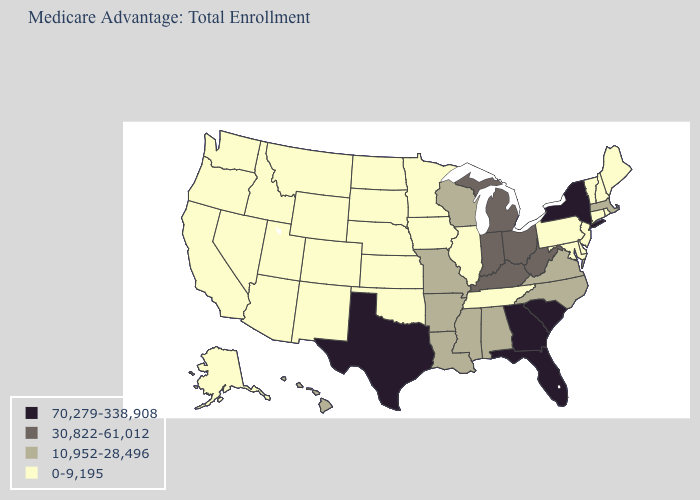What is the highest value in states that border Kentucky?
Write a very short answer. 30,822-61,012. Does the map have missing data?
Be succinct. No. Among the states that border Rhode Island , does Massachusetts have the highest value?
Write a very short answer. Yes. Does the map have missing data?
Quick response, please. No. Name the states that have a value in the range 10,952-28,496?
Be succinct. Alabama, Arkansas, Hawaii, Louisiana, Massachusetts, Missouri, Mississippi, North Carolina, Virginia, Wisconsin. Does Indiana have the lowest value in the USA?
Answer briefly. No. Among the states that border Indiana , which have the highest value?
Give a very brief answer. Kentucky, Michigan, Ohio. Does the first symbol in the legend represent the smallest category?
Short answer required. No. Does the first symbol in the legend represent the smallest category?
Give a very brief answer. No. What is the highest value in the USA?
Keep it brief. 70,279-338,908. Among the states that border Rhode Island , does Connecticut have the lowest value?
Be succinct. Yes. What is the lowest value in the USA?
Concise answer only. 0-9,195. Name the states that have a value in the range 10,952-28,496?
Quick response, please. Alabama, Arkansas, Hawaii, Louisiana, Massachusetts, Missouri, Mississippi, North Carolina, Virginia, Wisconsin. 